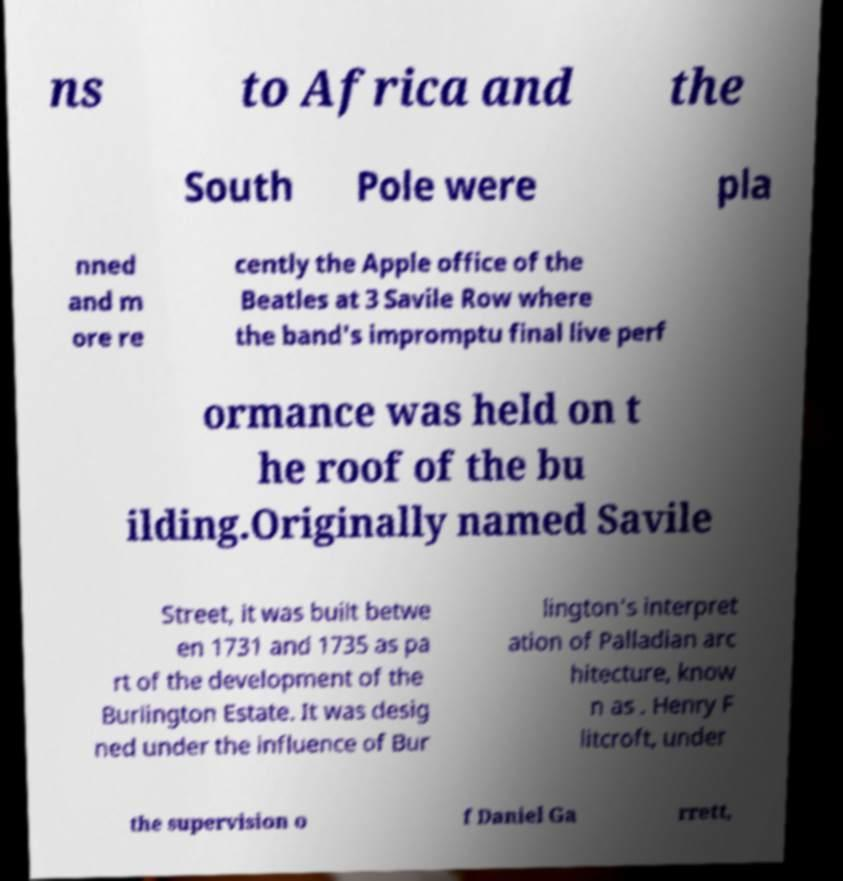Please read and relay the text visible in this image. What does it say? ns to Africa and the South Pole were pla nned and m ore re cently the Apple office of the Beatles at 3 Savile Row where the band's impromptu final live perf ormance was held on t he roof of the bu ilding.Originally named Savile Street, it was built betwe en 1731 and 1735 as pa rt of the development of the Burlington Estate. It was desig ned under the influence of Bur lington's interpret ation of Palladian arc hitecture, know n as . Henry F litcroft, under the supervision o f Daniel Ga rrett, 